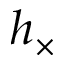<formula> <loc_0><loc_0><loc_500><loc_500>h _ { \times }</formula> 